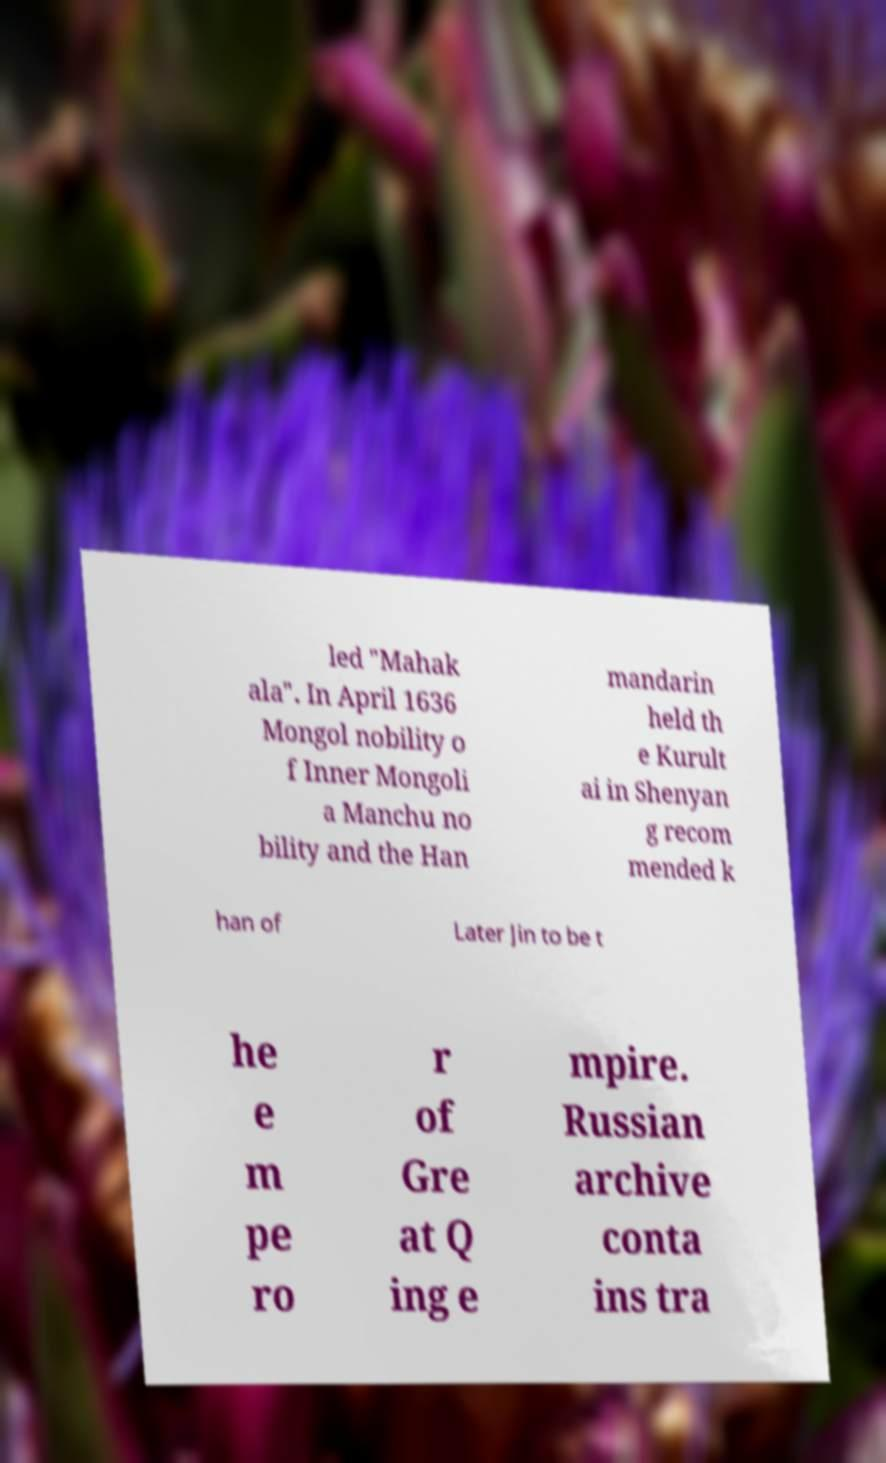I need the written content from this picture converted into text. Can you do that? led "Mahak ala". In April 1636 Mongol nobility o f Inner Mongoli a Manchu no bility and the Han mandarin held th e Kurult ai in Shenyan g recom mended k han of Later Jin to be t he e m pe ro r of Gre at Q ing e mpire. Russian archive conta ins tra 